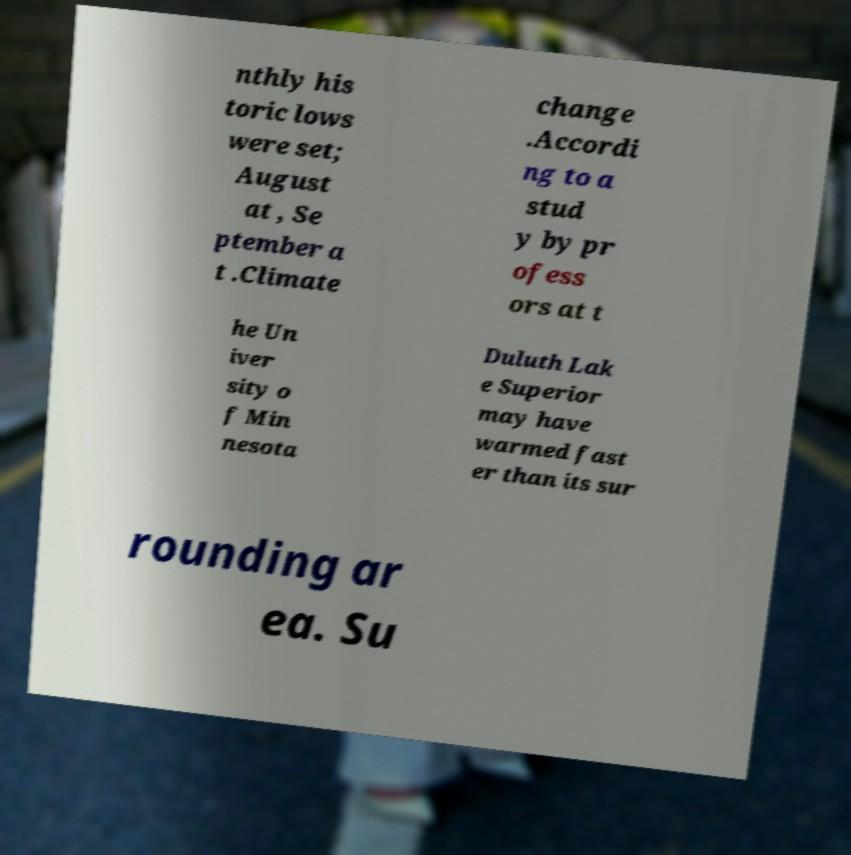I need the written content from this picture converted into text. Can you do that? nthly his toric lows were set; August at , Se ptember a t .Climate change .Accordi ng to a stud y by pr ofess ors at t he Un iver sity o f Min nesota Duluth Lak e Superior may have warmed fast er than its sur rounding ar ea. Su 